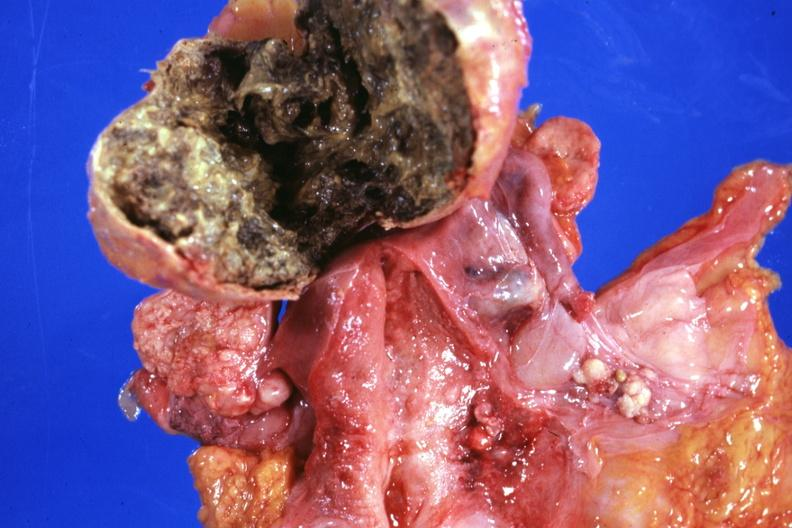where does this part belong to?
Answer the question using a single word or phrase. Female reproductive system 